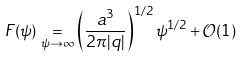Convert formula to latex. <formula><loc_0><loc_0><loc_500><loc_500>F ( \psi ) \underset { \psi \to \infty } { = } \left ( \frac { a ^ { 3 } } { 2 \pi | q | } \right ) ^ { 1 / 2 } \psi ^ { 1 / 2 } + \mathcal { O } ( 1 )</formula> 